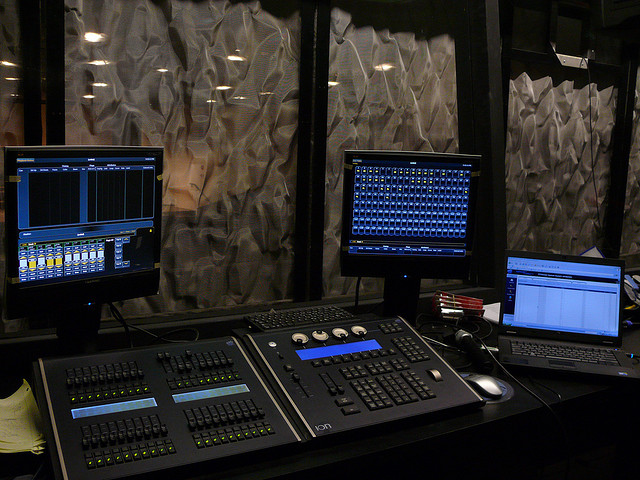Please extract the text content from this image. ION 